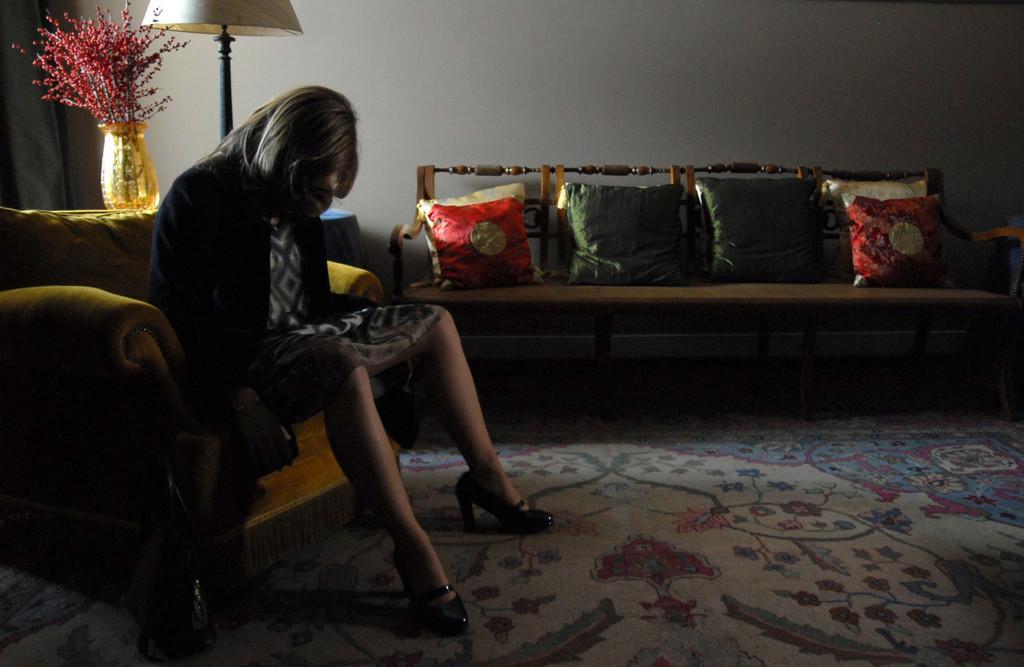In one or two sentences, can you explain what this image depicts? To the left side on the sofa there's a lady sitting. And in the middle there is another sofa with five pillows on it. Behind that lady there is a lamp and a flower vase on the table. There is a floor mat on the floor. 